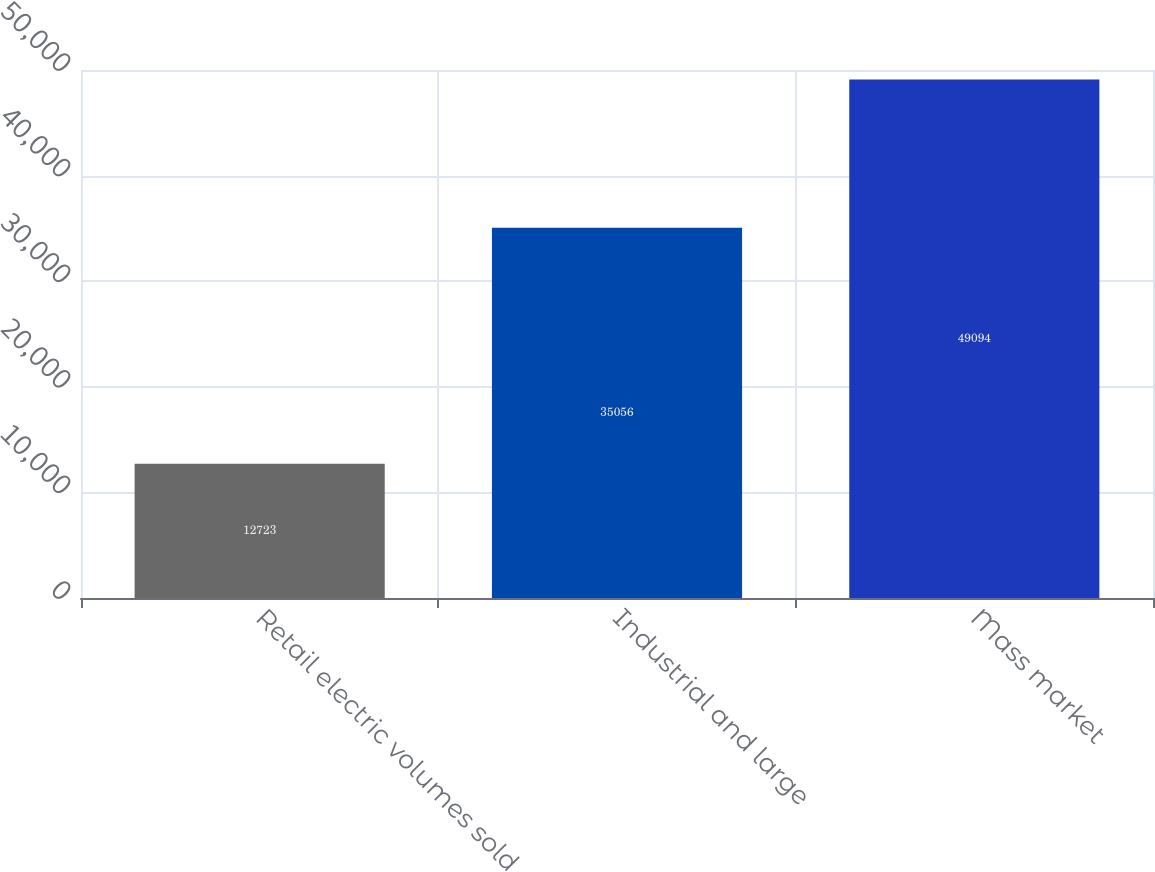Convert chart to OTSL. <chart><loc_0><loc_0><loc_500><loc_500><bar_chart><fcel>Retail electric volumes sold<fcel>Industrial and large<fcel>Mass market<nl><fcel>12723<fcel>35056<fcel>49094<nl></chart> 